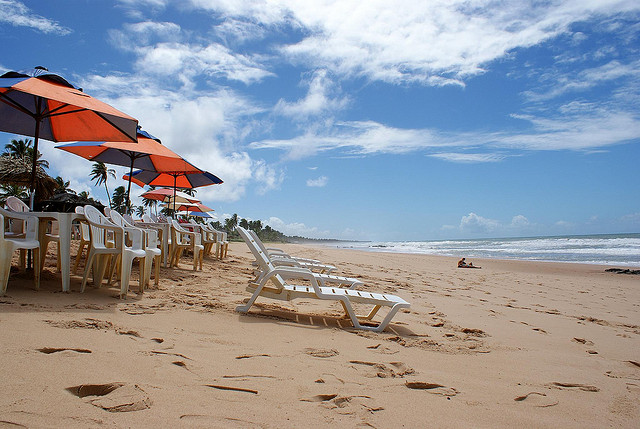What time of day does this picture look like it was taken? The image seems to have been captured in the mid-morning, based on the shadows cast by the beach umbrellas and the relatively calm ocean, which is common in the earlier parts of the day. 